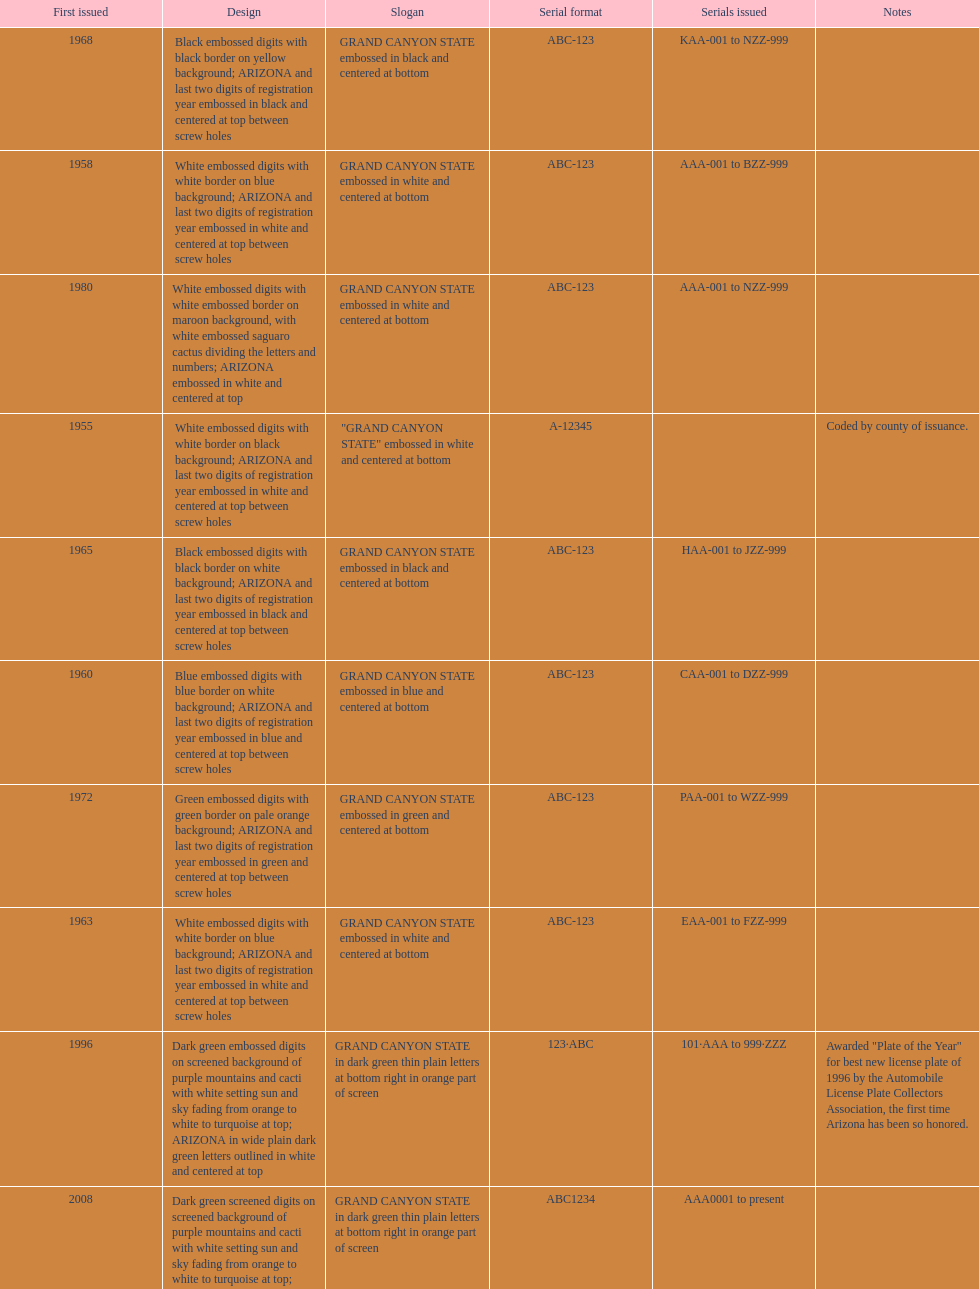What was year was the first arizona license plate made? 1955. 